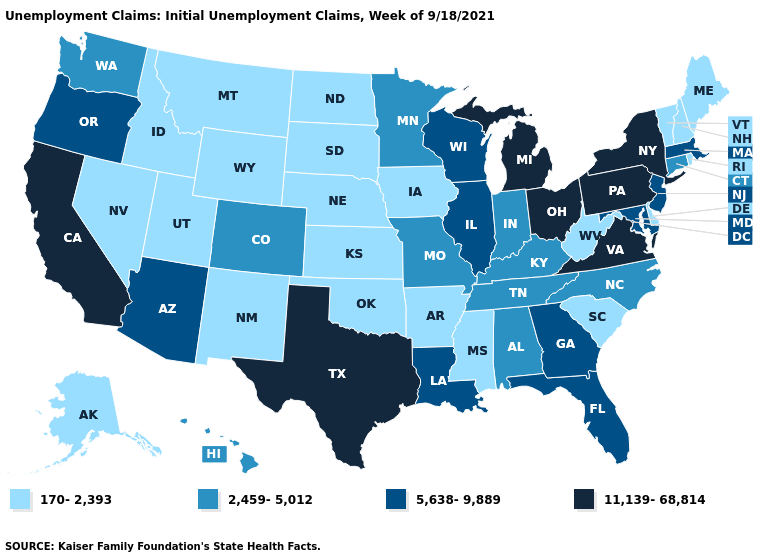What is the value of Nebraska?
Short answer required. 170-2,393. Among the states that border Oregon , does Nevada have the highest value?
Be succinct. No. Name the states that have a value in the range 170-2,393?
Concise answer only. Alaska, Arkansas, Delaware, Idaho, Iowa, Kansas, Maine, Mississippi, Montana, Nebraska, Nevada, New Hampshire, New Mexico, North Dakota, Oklahoma, Rhode Island, South Carolina, South Dakota, Utah, Vermont, West Virginia, Wyoming. Is the legend a continuous bar?
Quick response, please. No. Name the states that have a value in the range 170-2,393?
Answer briefly. Alaska, Arkansas, Delaware, Idaho, Iowa, Kansas, Maine, Mississippi, Montana, Nebraska, Nevada, New Hampshire, New Mexico, North Dakota, Oklahoma, Rhode Island, South Carolina, South Dakota, Utah, Vermont, West Virginia, Wyoming. Name the states that have a value in the range 2,459-5,012?
Concise answer only. Alabama, Colorado, Connecticut, Hawaii, Indiana, Kentucky, Minnesota, Missouri, North Carolina, Tennessee, Washington. Is the legend a continuous bar?
Write a very short answer. No. How many symbols are there in the legend?
Quick response, please. 4. Name the states that have a value in the range 11,139-68,814?
Short answer required. California, Michigan, New York, Ohio, Pennsylvania, Texas, Virginia. Name the states that have a value in the range 170-2,393?
Be succinct. Alaska, Arkansas, Delaware, Idaho, Iowa, Kansas, Maine, Mississippi, Montana, Nebraska, Nevada, New Hampshire, New Mexico, North Dakota, Oklahoma, Rhode Island, South Carolina, South Dakota, Utah, Vermont, West Virginia, Wyoming. Name the states that have a value in the range 2,459-5,012?
Quick response, please. Alabama, Colorado, Connecticut, Hawaii, Indiana, Kentucky, Minnesota, Missouri, North Carolina, Tennessee, Washington. Among the states that border North Dakota , which have the highest value?
Keep it brief. Minnesota. Among the states that border New Mexico , does Oklahoma have the lowest value?
Short answer required. Yes. What is the value of Idaho?
Write a very short answer. 170-2,393. 